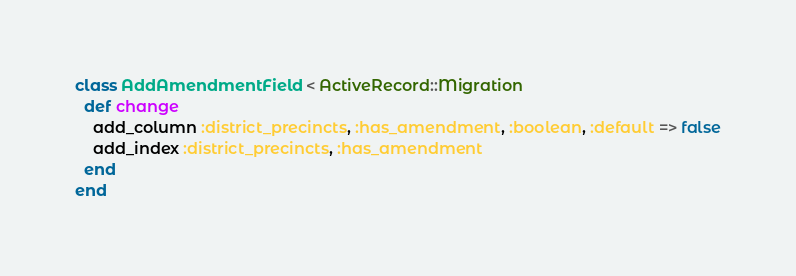<code> <loc_0><loc_0><loc_500><loc_500><_Ruby_>class AddAmendmentField < ActiveRecord::Migration
  def change
    add_column :district_precincts, :has_amendment, :boolean, :default => false
    add_index :district_precincts, :has_amendment
  end
end
</code> 